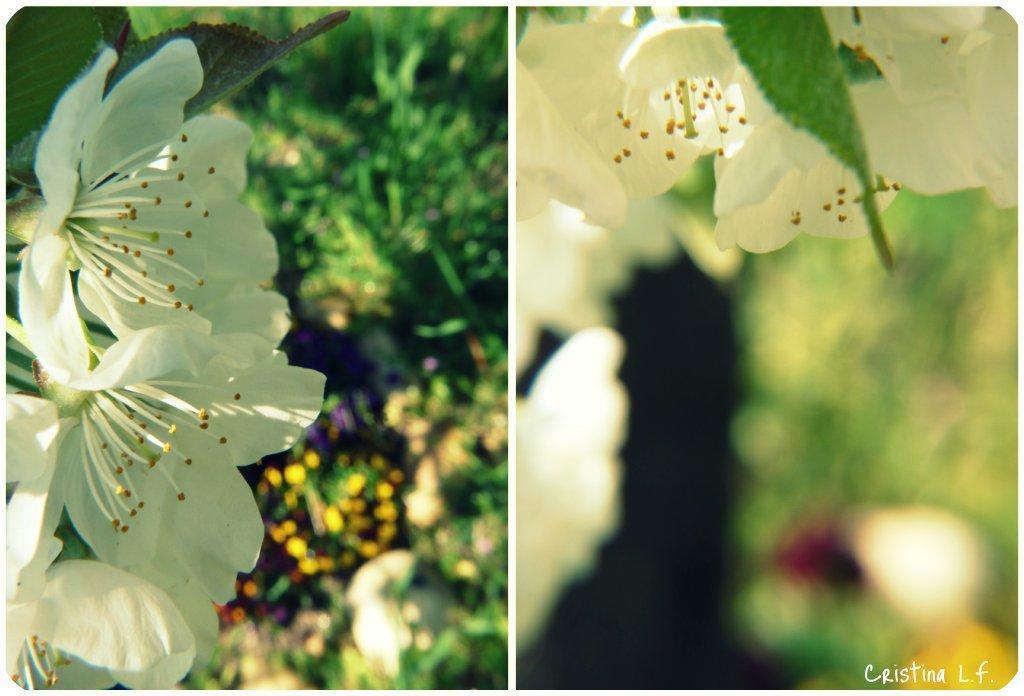Could you give a brief overview of what you see in this image? This is a collage image, in this image there are two pictures, in that pictures there are flowers on the bottom right there is some text. 